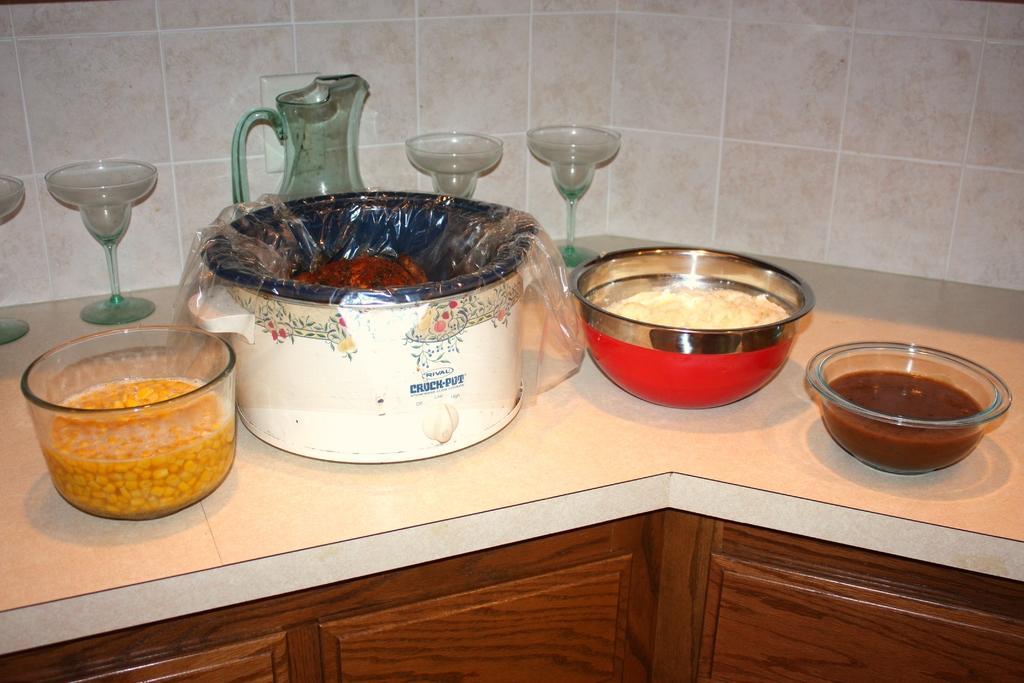Describe this image in one or two sentences. There is a platform with cupboards. On the platform there are glasses, jug, bowls and and a vessel. There are some items in the bowls. Also there is a plastic cover in the vessel. In the back there is a wall. 